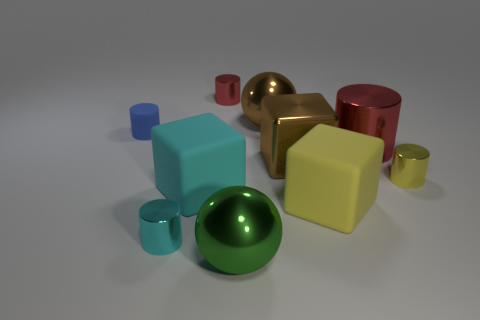Subtract all small red cylinders. How many cylinders are left? 4 Subtract 1 cylinders. How many cylinders are left? 4 Add 3 gray matte things. How many gray matte things exist? 3 Subtract all cyan blocks. How many blocks are left? 2 Subtract 0 blue blocks. How many objects are left? 10 Subtract all blocks. How many objects are left? 7 Subtract all green balls. Subtract all yellow cubes. How many balls are left? 1 Subtract all cyan spheres. How many red cylinders are left? 2 Subtract all small matte cubes. Subtract all green balls. How many objects are left? 9 Add 7 blue matte cylinders. How many blue matte cylinders are left? 8 